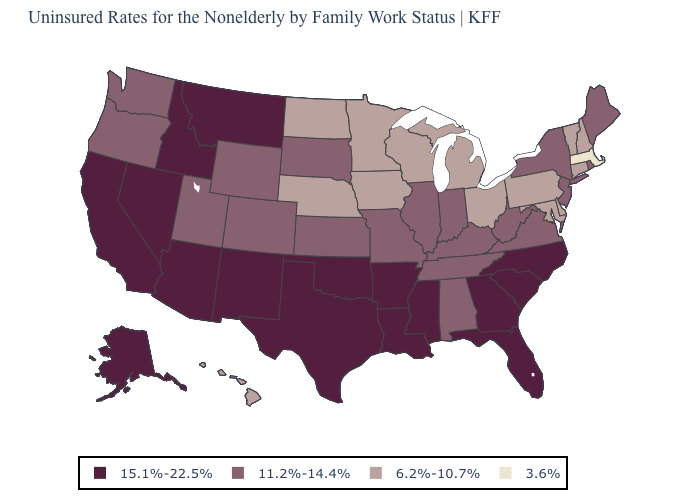Name the states that have a value in the range 15.1%-22.5%?
Give a very brief answer. Alaska, Arizona, Arkansas, California, Florida, Georgia, Idaho, Louisiana, Mississippi, Montana, Nevada, New Mexico, North Carolina, Oklahoma, South Carolina, Texas. Name the states that have a value in the range 6.2%-10.7%?
Write a very short answer. Connecticut, Delaware, Hawaii, Iowa, Maryland, Michigan, Minnesota, Nebraska, New Hampshire, North Dakota, Ohio, Pennsylvania, Vermont, Wisconsin. What is the value of Virginia?
Keep it brief. 11.2%-14.4%. Does Idaho have the highest value in the USA?
Be succinct. Yes. What is the highest value in the West ?
Write a very short answer. 15.1%-22.5%. What is the value of Missouri?
Concise answer only. 11.2%-14.4%. Does Texas have the highest value in the USA?
Short answer required. Yes. Does Massachusetts have the lowest value in the Northeast?
Answer briefly. Yes. What is the value of Ohio?
Write a very short answer. 6.2%-10.7%. Which states have the highest value in the USA?
Give a very brief answer. Alaska, Arizona, Arkansas, California, Florida, Georgia, Idaho, Louisiana, Mississippi, Montana, Nevada, New Mexico, North Carolina, Oklahoma, South Carolina, Texas. Does Florida have the lowest value in the South?
Short answer required. No. Is the legend a continuous bar?
Quick response, please. No. What is the value of South Dakota?
Keep it brief. 11.2%-14.4%. What is the value of Florida?
Be succinct. 15.1%-22.5%. 